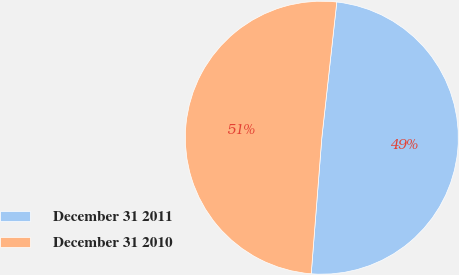Convert chart to OTSL. <chart><loc_0><loc_0><loc_500><loc_500><pie_chart><fcel>December 31 2011<fcel>December 31 2010<nl><fcel>49.49%<fcel>50.51%<nl></chart> 